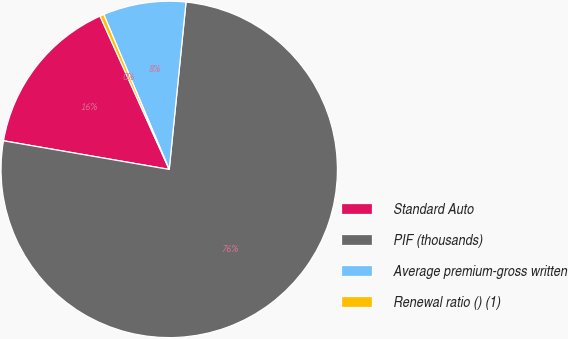<chart> <loc_0><loc_0><loc_500><loc_500><pie_chart><fcel>Standard Auto<fcel>PIF (thousands)<fcel>Average premium-gross written<fcel>Renewal ratio () (1)<nl><fcel>15.53%<fcel>76.13%<fcel>7.96%<fcel>0.38%<nl></chart> 